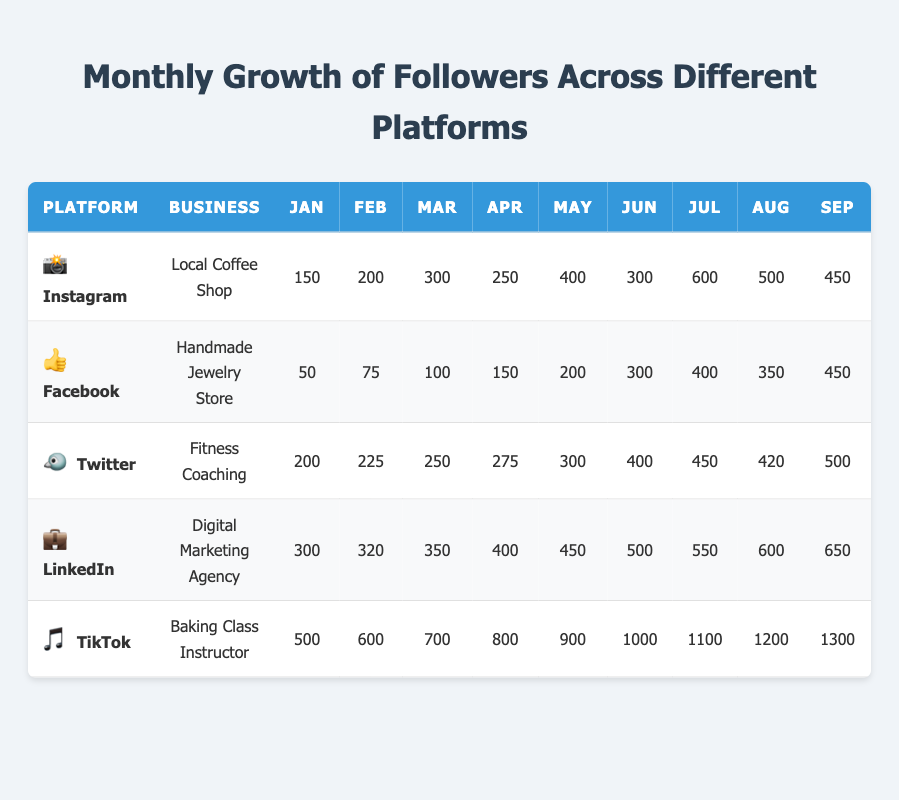What was the highest growth in followers for TikTok in December? The table shows that TikTok had 1600 followers in December, which is its highest growth in that month.
Answer: 1600 Which platform had the highest total follower growth over the year? By summing the monthly growth values for each platform, TikTok (1600) had the highest total follower growth compared to the others, followed by Instagram.
Answer: TikTok In which month did the Local Coffee Shop experience its highest follower growth on Instagram? Referring to the table, the highest growth for the Local Coffee Shop on Instagram was in December, with 900 followers gained.
Answer: December Did the Handmade Jewelry Store's followers ever reach 700 in a month? Yes, the Handmade Jewelry Store's followers reached exactly 700 in November according to the table.
Answer: Yes What was the average monthly growth of followers for the Fitness Coaching business on Twitter? Summing the monthly growth (200 + 225 + 250 + 275 + 300 + 400 + 450 + 420 + 500 + 550 + 600 + 700 = 4325) and dividing by the number of months (12), the average growth is 4325 / 12 = 360.42
Answer: 360.42 What is the trend of follower growth for LinkedIn? Observing the monthly growth numbers, LinkedIn shows a consistent increasing trend from January to December, indicating steady follower growth throughout the year.
Answer: Increasing trend Which platform had the lowest total growth across all months? By summing the monthly growth of each platform, Facebook had the lowest total growth, with 4050 followers over the year.
Answer: Facebook How many more followers did the Baking Class Instructor gain on TikTok in October than in February? In February, TikTok had 600 followers, and in October it had 1400. The difference is 1400 - 600 = 800.
Answer: 800 Which platform achieved the highest single-month gain, and in which month did it occur? Looking through the table, the Local Coffee Shop on Instagram had the highest single-month gain in November with 800 followers, while TikTok had a rise of 800 in April.
Answer: Instagram in November If you average the monthly growth from January to March for all platforms, what would that average be? The monthly growth from January to March for each platform is summed first: 150+200+300 (Instagram) + 50+75+100 (Facebook) + 200+225+250 (Twitter) + 300+320+350 (LinkedIn) + 500+600+700 (TikTok) = 3275. There are 5 platforms and 3 months, so the average is 3275 / 15 = 218.33.
Answer: 218.33 